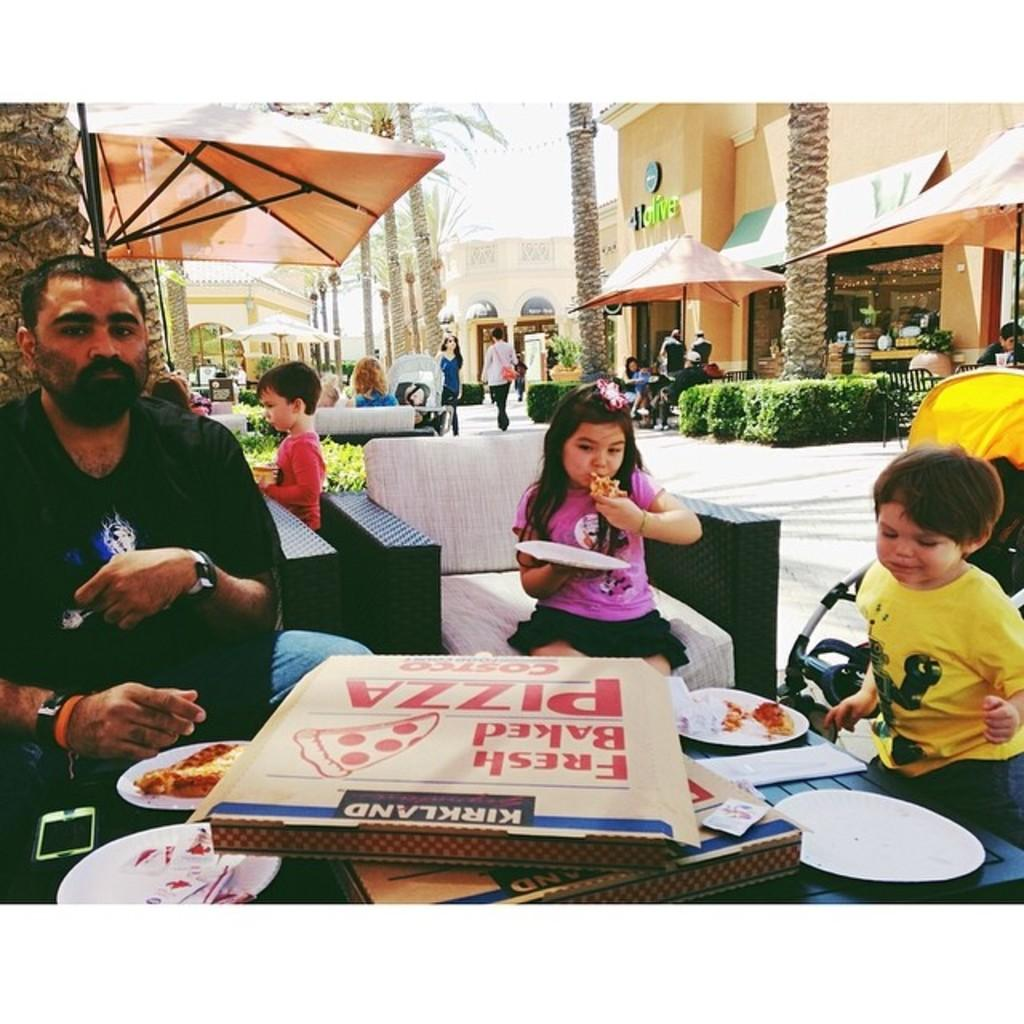What is on the table in the image? There is a box labeled "fresh baked pizza" on the table. How many people are sitting around the table? There are three people sitting around the table. What can be seen in the background of the image? Trees and buildings are visible in the background. What type of government is depicted in the image? There is no depiction of a government in the image; it features a box of pizza and people sitting around a table. What kind of blade is being used by one of the people in the image? There is no blade present in the image; it only shows a box of pizza and people sitting around a table. 